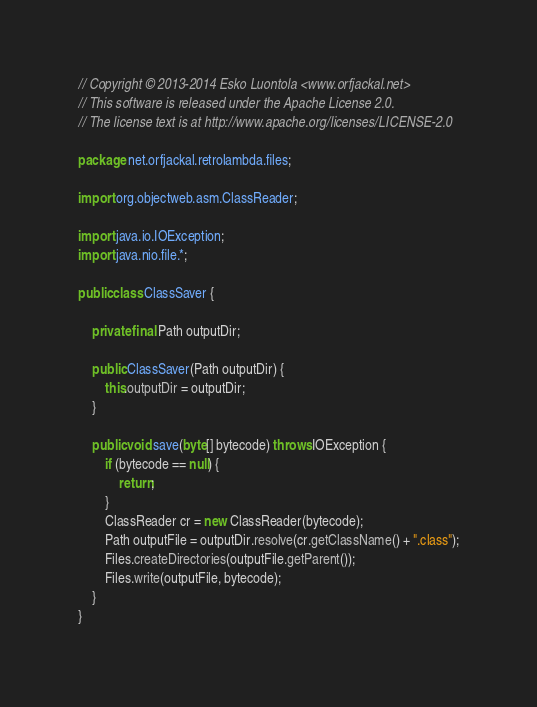<code> <loc_0><loc_0><loc_500><loc_500><_Java_>// Copyright © 2013-2014 Esko Luontola <www.orfjackal.net>
// This software is released under the Apache License 2.0.
// The license text is at http://www.apache.org/licenses/LICENSE-2.0

package net.orfjackal.retrolambda.files;

import org.objectweb.asm.ClassReader;

import java.io.IOException;
import java.nio.file.*;

public class ClassSaver {

    private final Path outputDir;

    public ClassSaver(Path outputDir) {
        this.outputDir = outputDir;
    }

    public void save(byte[] bytecode) throws IOException {
        if (bytecode == null) {
            return;
        }
        ClassReader cr = new ClassReader(bytecode);
        Path outputFile = outputDir.resolve(cr.getClassName() + ".class");
        Files.createDirectories(outputFile.getParent());
        Files.write(outputFile, bytecode);
    }
}
</code> 